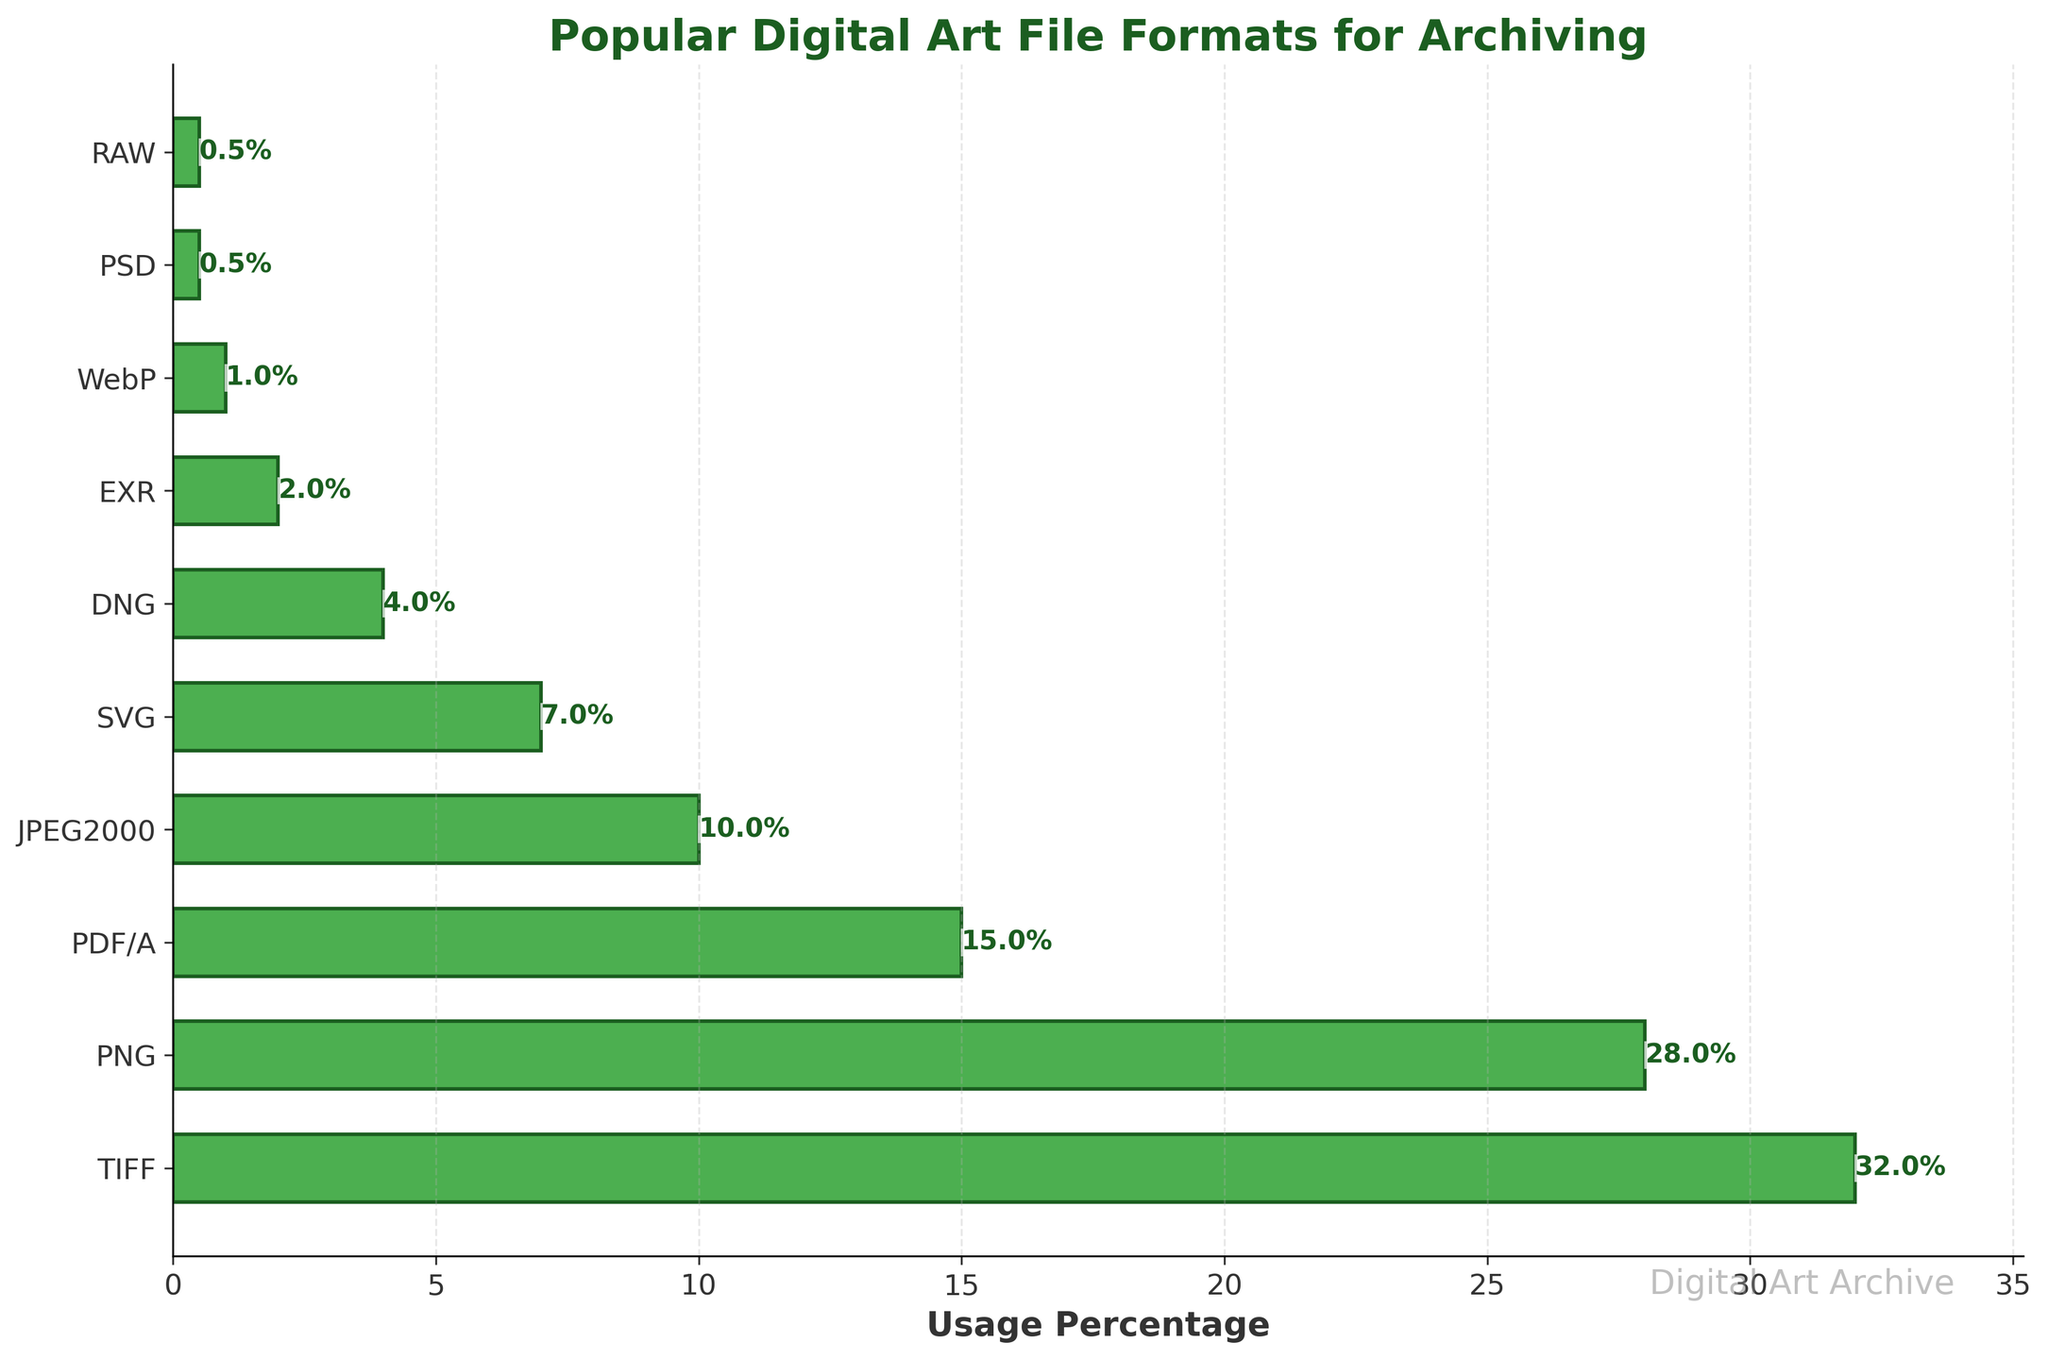What's the most popular digital art file format for archiving? To find the most popular format, look at the bar with the highest value in the chart. The bar labeled "TIFF" has the highest usage percentage of 32%.
Answer: TIFF Which two formats have a combined usage percentage of 50%? Add the usage percentages of different formats to find the ones that sum to 50%. The formats "TIFF" (32%) and "PNG" (28%) together exceed 50%, but using "TIFF" (32%) and "PDF/A" (15%) gives 47%, which is closest to 50% without exceeding it.
Answer: TIFF and PDF/A Which file formats have a usage percentage less than 5%? Identify all bars with usage percentages less than 5%. These formats are "DNG" (4%), "EXR" (2%), "WebP" (1%), "PSD" (0.5%), and "RAW" (0.5%).
Answer: DNG, EXR, WebP, PSD, RAW How much more popular is PNG compared to JPEG2000? Subtract the usage percentage of JPEG2000 from that of PNG. PNG has 28% and JPEG2000 has 10%. So, the difference is 28% - 10%.
Answer: 18% What is the total usage percentage of all formats combined? Add up all the usage percentages. 32% (TIFF) + 28% (PNG) + 15% (PDF/A) + 10% (JPEG2000) + 7% (SVG) + 4% (DNG) + 2% (EXR) + 1% (WebP) + 0.5% (PSD) + 0.5% (RAW). This sums up to 100%.
Answer: 100% Which format has a usage percentage closest to the average usage percentage of all formats? Calculate the average of all percentages. Sum is 100% for 10 formats, so average = 100% / 10 = 10%. The format closest to this average is "JPEG2000" with 10%.
Answer: JPEG2000 Which format has the smallest visual bar on the chart? Identify the bar with the smallest height on the horizontal axis. Both "PSD" and "RAW" have the smallest bars with a usage percentage of 0.5%.
Answer: PSD and RAW 